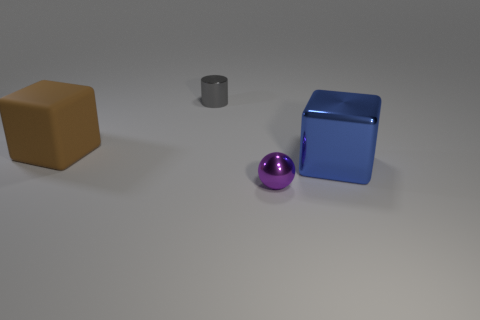How many other objects are the same size as the blue metallic thing?
Give a very brief answer. 1. How many small objects are either matte objects or purple cylinders?
Make the answer very short. 0. Is the size of the rubber block the same as the shiny thing behind the matte thing?
Your answer should be very brief. No. What number of other objects are the same shape as the large blue metal thing?
Give a very brief answer. 1. What is the shape of the tiny thing that is the same material as the sphere?
Your answer should be compact. Cylinder. Are there any matte cylinders?
Make the answer very short. No. Is the number of large brown rubber things to the right of the brown matte cube less than the number of large matte things in front of the large blue object?
Your answer should be compact. No. What is the shape of the big thing in front of the large brown matte object?
Provide a succinct answer. Cube. Is the material of the big blue object the same as the tiny gray cylinder?
Offer a terse response. Yes. Are there any other things that are the same material as the brown object?
Offer a terse response. No. 